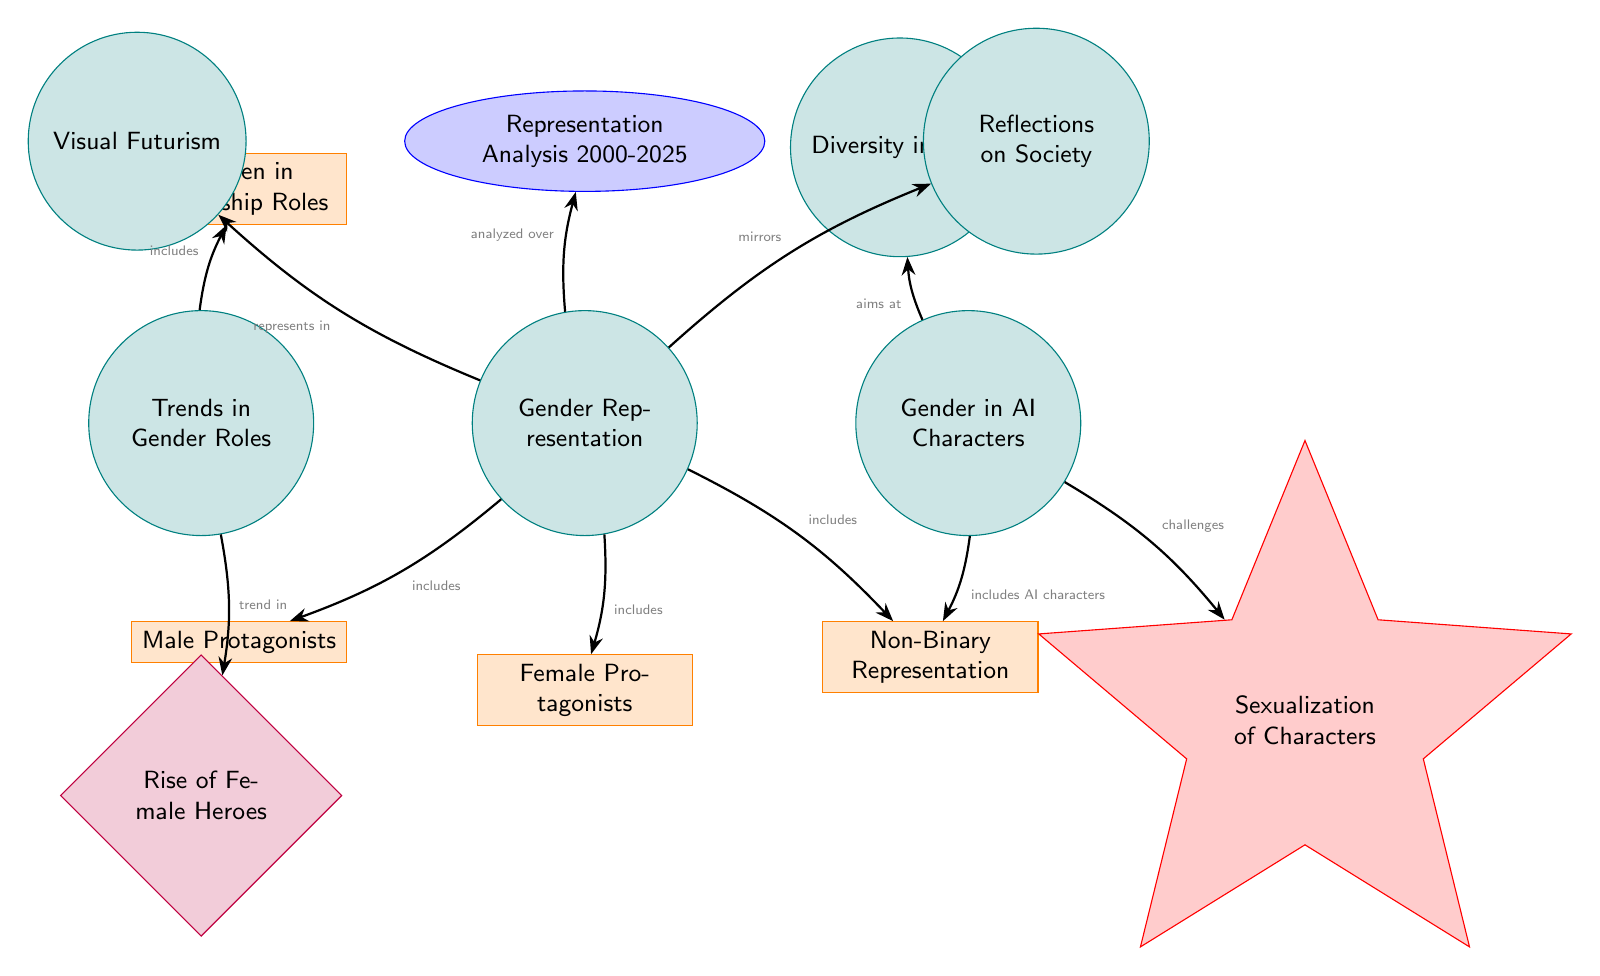What nodes are included under Gender Representation? The nodes under Gender Representation are Male Protagonists, Female Protagonists, and Non-Binary Representation, which are directly linked from the Gender Representation node to denote inclusivity.
Answer: Male Protagonists, Female Protagonists, Non-Binary Representation How many trends are identified in Trends in Gender Roles? There is one trend indicated under Trends in Gender Roles, which is the Rise of Female Heroes, and it is connected directly to the Trends in Gender Roles node.
Answer: One Which node addresses the issue of character sexualization? The Sexualization of Characters node addresses issues related to how characters are depicted, connecting to the Gender in AI Characters node to show its relevance.
Answer: Sexualization of Characters What relationship exists between Gender Representation and Visual Futurism? The relationship is noted as "represents in", suggesting that Gender Representation is portrayed through visual futurism in futuristic films.
Answer: Represents in What does the Representation Analysis node cover? The Representation Analysis node spans the time frame from 2000 to 2025, indicating the timeline for analyzing gender representation in films.
Answer: 2000-2025 How many main categories are depicted under Gender Representation? There are three main categories depicted, which are Male Protagonists, Female Protagonists, and Non-Binary Representation, clearly outlined in the diagram.
Answer: Three What main concept is associated with AI characters in the diagram? The main concept associated with AI characters is Diversity in Cast, indicating a focus on various identities in the portrayal of AI characters.
Answer: Diversity in Cast How is the theme of Women in Leadership Roles categorized in the diagram? The theme of Women in Leadership Roles is categorized under Trends in Gender Roles, suggesting its relevance to the evolving representation of gender in films.
Answer: Trends in Gender Roles What type of diagram is this representation? This is a Social Science Diagram, as it analyzes the social aspect of gender representation in futuristic films.
Answer: Social Science Diagram 